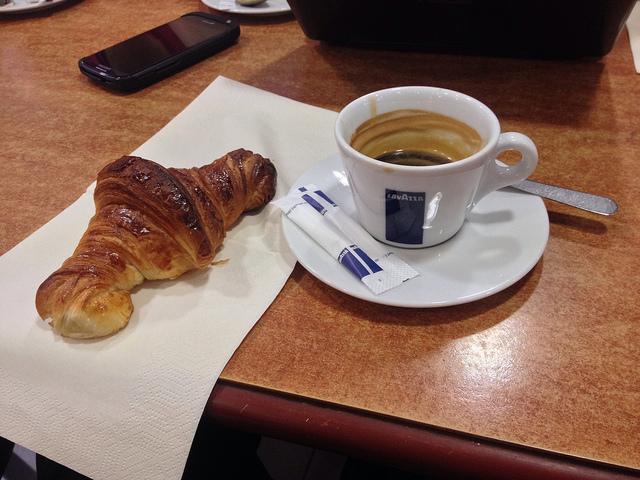What color is the block in the middle of the cup on the right?
From the following set of four choices, select the accurate answer to respond to the question.
Options: Purple, green, blue, red. Blue. 